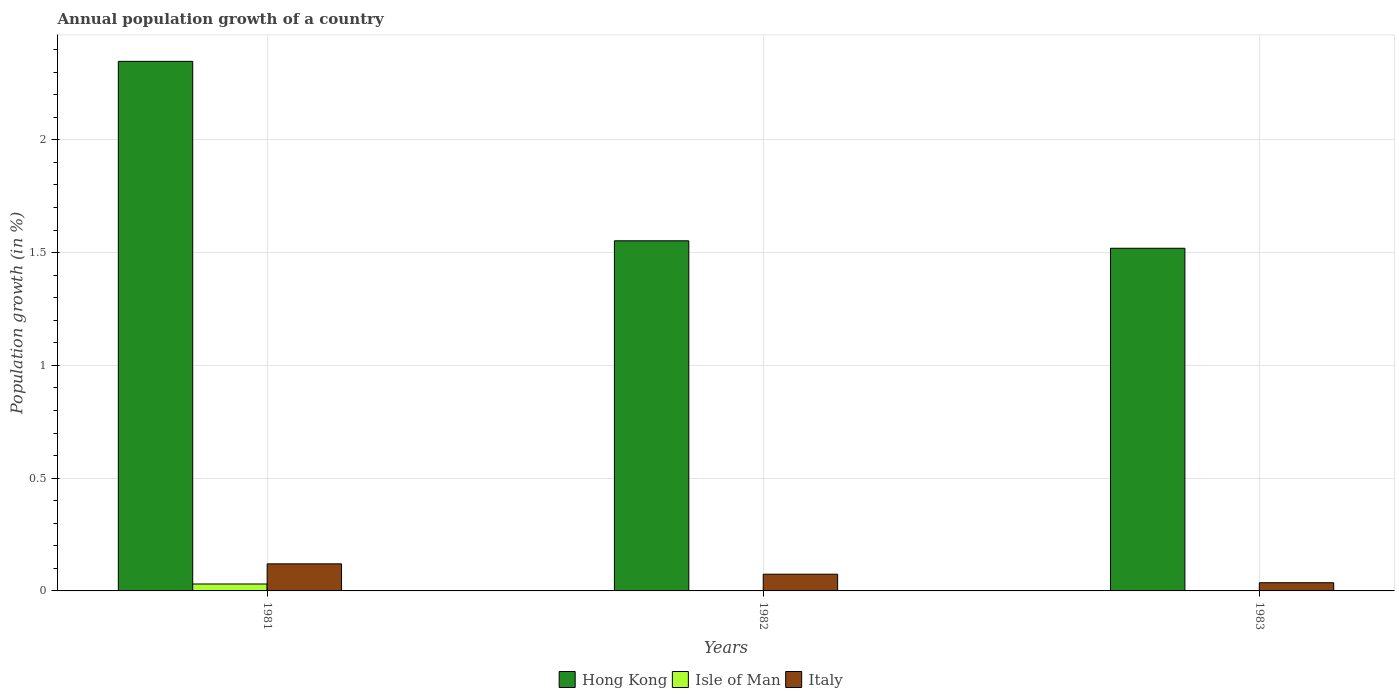Are the number of bars per tick equal to the number of legend labels?
Provide a succinct answer. No. How many bars are there on the 3rd tick from the left?
Make the answer very short. 2. How many bars are there on the 2nd tick from the right?
Your answer should be very brief. 2. What is the label of the 2nd group of bars from the left?
Your response must be concise. 1982. In how many cases, is the number of bars for a given year not equal to the number of legend labels?
Provide a succinct answer. 2. What is the annual population growth in Italy in 1983?
Ensure brevity in your answer.  0.04. Across all years, what is the maximum annual population growth in Hong Kong?
Offer a very short reply. 2.35. Across all years, what is the minimum annual population growth in Hong Kong?
Your response must be concise. 1.52. What is the total annual population growth in Italy in the graph?
Your answer should be compact. 0.23. What is the difference between the annual population growth in Hong Kong in 1981 and that in 1983?
Ensure brevity in your answer.  0.83. What is the difference between the annual population growth in Hong Kong in 1981 and the annual population growth in Isle of Man in 1983?
Your answer should be very brief. 2.35. What is the average annual population growth in Italy per year?
Your response must be concise. 0.08. In the year 1983, what is the difference between the annual population growth in Italy and annual population growth in Hong Kong?
Your answer should be very brief. -1.48. In how many years, is the annual population growth in Italy greater than 1.6 %?
Your response must be concise. 0. What is the ratio of the annual population growth in Italy in 1981 to that in 1983?
Offer a very short reply. 3.31. Is the annual population growth in Italy in 1982 less than that in 1983?
Keep it short and to the point. No. What is the difference between the highest and the second highest annual population growth in Hong Kong?
Your answer should be compact. 0.8. What is the difference between the highest and the lowest annual population growth in Italy?
Your answer should be very brief. 0.08. In how many years, is the annual population growth in Isle of Man greater than the average annual population growth in Isle of Man taken over all years?
Provide a short and direct response. 1. Is it the case that in every year, the sum of the annual population growth in Hong Kong and annual population growth in Isle of Man is greater than the annual population growth in Italy?
Provide a short and direct response. Yes. How many bars are there?
Keep it short and to the point. 7. Are all the bars in the graph horizontal?
Your answer should be compact. No. What is the difference between two consecutive major ticks on the Y-axis?
Your answer should be very brief. 0.5. How are the legend labels stacked?
Provide a short and direct response. Horizontal. What is the title of the graph?
Your answer should be compact. Annual population growth of a country. Does "Small states" appear as one of the legend labels in the graph?
Your response must be concise. No. What is the label or title of the X-axis?
Keep it short and to the point. Years. What is the label or title of the Y-axis?
Keep it short and to the point. Population growth (in %). What is the Population growth (in %) in Hong Kong in 1981?
Make the answer very short. 2.35. What is the Population growth (in %) of Isle of Man in 1981?
Your answer should be very brief. 0.03. What is the Population growth (in %) of Italy in 1981?
Your answer should be compact. 0.12. What is the Population growth (in %) of Hong Kong in 1982?
Offer a very short reply. 1.55. What is the Population growth (in %) of Italy in 1982?
Ensure brevity in your answer.  0.07. What is the Population growth (in %) in Hong Kong in 1983?
Offer a very short reply. 1.52. What is the Population growth (in %) of Isle of Man in 1983?
Give a very brief answer. 0. What is the Population growth (in %) in Italy in 1983?
Your response must be concise. 0.04. Across all years, what is the maximum Population growth (in %) in Hong Kong?
Offer a very short reply. 2.35. Across all years, what is the maximum Population growth (in %) of Isle of Man?
Keep it short and to the point. 0.03. Across all years, what is the maximum Population growth (in %) of Italy?
Provide a succinct answer. 0.12. Across all years, what is the minimum Population growth (in %) in Hong Kong?
Make the answer very short. 1.52. Across all years, what is the minimum Population growth (in %) in Isle of Man?
Offer a very short reply. 0. Across all years, what is the minimum Population growth (in %) in Italy?
Keep it short and to the point. 0.04. What is the total Population growth (in %) in Hong Kong in the graph?
Ensure brevity in your answer.  5.42. What is the total Population growth (in %) in Isle of Man in the graph?
Make the answer very short. 0.03. What is the total Population growth (in %) in Italy in the graph?
Your answer should be compact. 0.23. What is the difference between the Population growth (in %) in Hong Kong in 1981 and that in 1982?
Your answer should be very brief. 0.8. What is the difference between the Population growth (in %) of Italy in 1981 and that in 1982?
Your answer should be very brief. 0.05. What is the difference between the Population growth (in %) of Hong Kong in 1981 and that in 1983?
Offer a very short reply. 0.83. What is the difference between the Population growth (in %) of Italy in 1981 and that in 1983?
Keep it short and to the point. 0.08. What is the difference between the Population growth (in %) of Hong Kong in 1982 and that in 1983?
Your answer should be very brief. 0.03. What is the difference between the Population growth (in %) in Italy in 1982 and that in 1983?
Give a very brief answer. 0.04. What is the difference between the Population growth (in %) of Hong Kong in 1981 and the Population growth (in %) of Italy in 1982?
Provide a succinct answer. 2.27. What is the difference between the Population growth (in %) of Isle of Man in 1981 and the Population growth (in %) of Italy in 1982?
Your response must be concise. -0.04. What is the difference between the Population growth (in %) in Hong Kong in 1981 and the Population growth (in %) in Italy in 1983?
Provide a succinct answer. 2.31. What is the difference between the Population growth (in %) in Isle of Man in 1981 and the Population growth (in %) in Italy in 1983?
Give a very brief answer. -0.01. What is the difference between the Population growth (in %) in Hong Kong in 1982 and the Population growth (in %) in Italy in 1983?
Your answer should be compact. 1.52. What is the average Population growth (in %) of Hong Kong per year?
Give a very brief answer. 1.81. What is the average Population growth (in %) in Isle of Man per year?
Your answer should be compact. 0.01. What is the average Population growth (in %) of Italy per year?
Give a very brief answer. 0.08. In the year 1981, what is the difference between the Population growth (in %) of Hong Kong and Population growth (in %) of Isle of Man?
Your answer should be very brief. 2.32. In the year 1981, what is the difference between the Population growth (in %) of Hong Kong and Population growth (in %) of Italy?
Ensure brevity in your answer.  2.23. In the year 1981, what is the difference between the Population growth (in %) in Isle of Man and Population growth (in %) in Italy?
Your answer should be compact. -0.09. In the year 1982, what is the difference between the Population growth (in %) in Hong Kong and Population growth (in %) in Italy?
Offer a very short reply. 1.48. In the year 1983, what is the difference between the Population growth (in %) of Hong Kong and Population growth (in %) of Italy?
Make the answer very short. 1.48. What is the ratio of the Population growth (in %) of Hong Kong in 1981 to that in 1982?
Make the answer very short. 1.51. What is the ratio of the Population growth (in %) of Italy in 1981 to that in 1982?
Your answer should be compact. 1.62. What is the ratio of the Population growth (in %) in Hong Kong in 1981 to that in 1983?
Your answer should be very brief. 1.55. What is the ratio of the Population growth (in %) in Italy in 1981 to that in 1983?
Give a very brief answer. 3.31. What is the ratio of the Population growth (in %) in Hong Kong in 1982 to that in 1983?
Offer a terse response. 1.02. What is the ratio of the Population growth (in %) in Italy in 1982 to that in 1983?
Offer a terse response. 2.04. What is the difference between the highest and the second highest Population growth (in %) of Hong Kong?
Keep it short and to the point. 0.8. What is the difference between the highest and the second highest Population growth (in %) in Italy?
Provide a short and direct response. 0.05. What is the difference between the highest and the lowest Population growth (in %) in Hong Kong?
Ensure brevity in your answer.  0.83. What is the difference between the highest and the lowest Population growth (in %) in Isle of Man?
Your answer should be compact. 0.03. What is the difference between the highest and the lowest Population growth (in %) of Italy?
Make the answer very short. 0.08. 